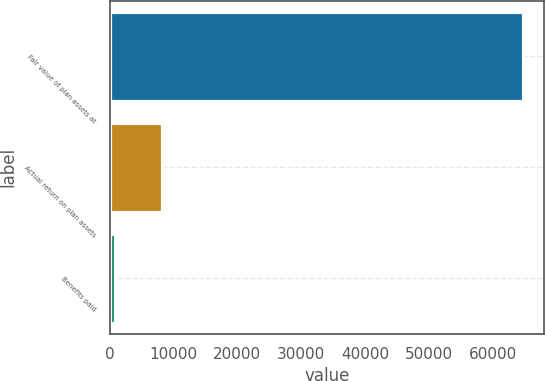<chart> <loc_0><loc_0><loc_500><loc_500><bar_chart><fcel>Fair value of plan assets at<fcel>Actual return on plan assets<fcel>Benefits paid<nl><fcel>64772<fcel>8200<fcel>797<nl></chart> 